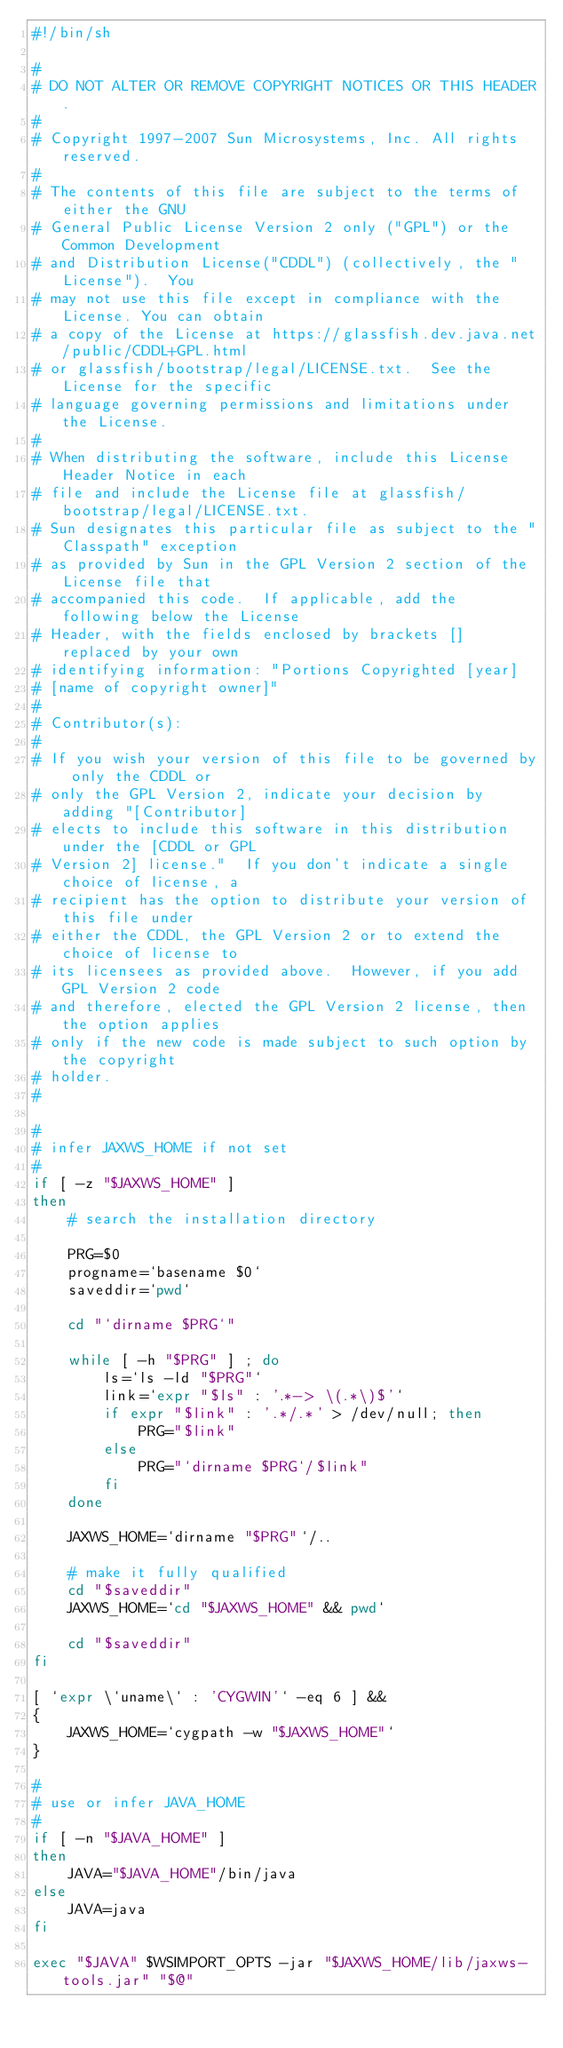Convert code to text. <code><loc_0><loc_0><loc_500><loc_500><_Bash_>#!/bin/sh

#
# DO NOT ALTER OR REMOVE COPYRIGHT NOTICES OR THIS HEADER.
# 
# Copyright 1997-2007 Sun Microsystems, Inc. All rights reserved.
# 
# The contents of this file are subject to the terms of either the GNU
# General Public License Version 2 only ("GPL") or the Common Development
# and Distribution License("CDDL") (collectively, the "License").  You
# may not use this file except in compliance with the License. You can obtain
# a copy of the License at https://glassfish.dev.java.net/public/CDDL+GPL.html
# or glassfish/bootstrap/legal/LICENSE.txt.  See the License for the specific
# language governing permissions and limitations under the License.
# 
# When distributing the software, include this License Header Notice in each
# file and include the License file at glassfish/bootstrap/legal/LICENSE.txt.
# Sun designates this particular file as subject to the "Classpath" exception
# as provided by Sun in the GPL Version 2 section of the License file that
# accompanied this code.  If applicable, add the following below the License
# Header, with the fields enclosed by brackets [] replaced by your own
# identifying information: "Portions Copyrighted [year]
# [name of copyright owner]"
# 
# Contributor(s):
# 
# If you wish your version of this file to be governed by only the CDDL or
# only the GPL Version 2, indicate your decision by adding "[Contributor]
# elects to include this software in this distribution under the [CDDL or GPL
# Version 2] license."  If you don't indicate a single choice of license, a
# recipient has the option to distribute your version of this file under
# either the CDDL, the GPL Version 2 or to extend the choice of license to
# its licensees as provided above.  However, if you add GPL Version 2 code
# and therefore, elected the GPL Version 2 license, then the option applies
# only if the new code is made subject to such option by the copyright
# holder.
#

#
# infer JAXWS_HOME if not set
#
if [ -z "$JAXWS_HOME" ]
then
    # search the installation directory
    
    PRG=$0
    progname=`basename $0`
    saveddir=`pwd`
    
    cd "`dirname $PRG`"
    
    while [ -h "$PRG" ] ; do
        ls=`ls -ld "$PRG"`
        link=`expr "$ls" : '.*-> \(.*\)$'`
        if expr "$link" : '.*/.*' > /dev/null; then
            PRG="$link"
        else
            PRG="`dirname $PRG`/$link"
        fi
    done

    JAXWS_HOME=`dirname "$PRG"`/..
    
    # make it fully qualified
    cd "$saveddir"
    JAXWS_HOME=`cd "$JAXWS_HOME" && pwd`
    
    cd "$saveddir"
fi

[ `expr \`uname\` : 'CYGWIN'` -eq 6 ] &&
{
    JAXWS_HOME=`cygpath -w "$JAXWS_HOME"`
}

#
# use or infer JAVA_HOME
#
if [ -n "$JAVA_HOME" ]
then
    JAVA="$JAVA_HOME"/bin/java
else
    JAVA=java
fi

exec "$JAVA" $WSIMPORT_OPTS -jar "$JAXWS_HOME/lib/jaxws-tools.jar" "$@"
</code> 